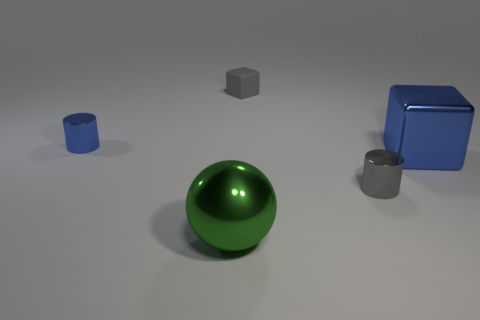There is a tiny thing to the left of the big metal ball; what shape is it?
Provide a succinct answer. Cylinder. There is a large object that is behind the gray object in front of the tiny gray matte block; what number of green metallic balls are behind it?
Provide a short and direct response. 0. Does the large metallic object in front of the metallic cube have the same color as the small block?
Make the answer very short. No. How many other objects are there of the same shape as the big blue thing?
Ensure brevity in your answer.  1. How many other objects are there of the same material as the blue cylinder?
Provide a succinct answer. 3. The tiny gray object left of the cylinder on the right side of the blue shiny thing that is on the left side of the green object is made of what material?
Provide a succinct answer. Rubber. Is the tiny gray cylinder made of the same material as the gray block?
Give a very brief answer. No. What number of blocks are big green metal things or gray matte objects?
Your answer should be very brief. 1. What is the color of the tiny cylinder that is in front of the big blue thing?
Provide a short and direct response. Gray. What number of metal objects are big objects or small blue things?
Provide a short and direct response. 3. 